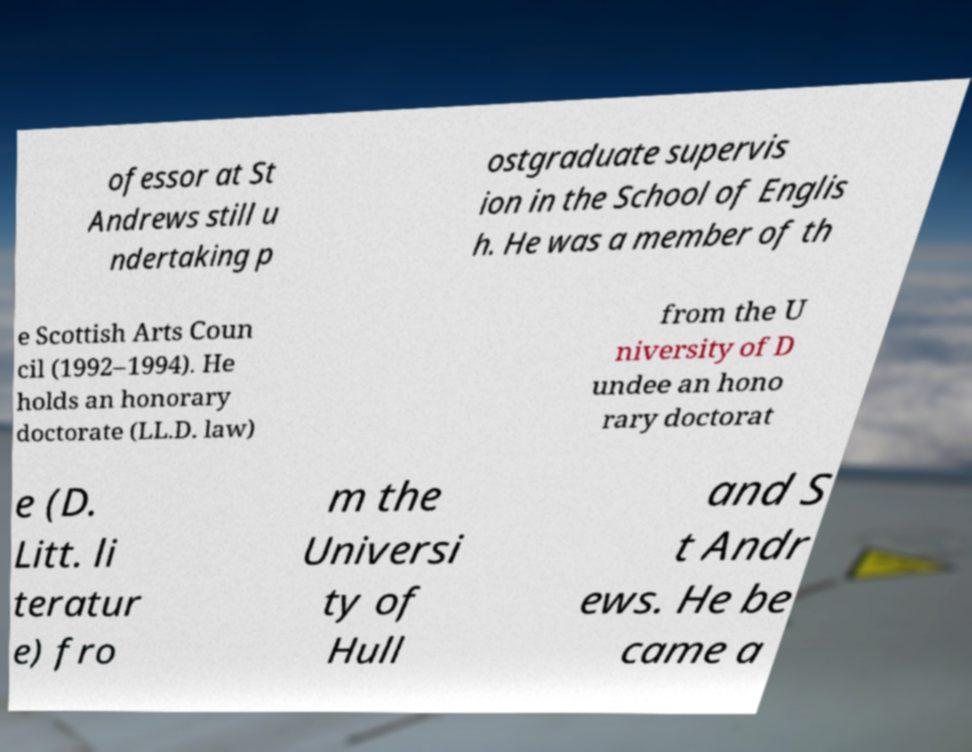I need the written content from this picture converted into text. Can you do that? ofessor at St Andrews still u ndertaking p ostgraduate supervis ion in the School of Englis h. He was a member of th e Scottish Arts Coun cil (1992–1994). He holds an honorary doctorate (LL.D. law) from the U niversity of D undee an hono rary doctorat e (D. Litt. li teratur e) fro m the Universi ty of Hull and S t Andr ews. He be came a 